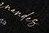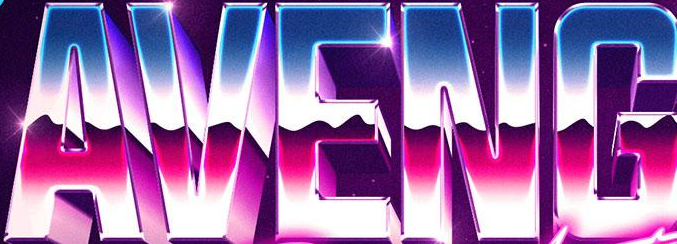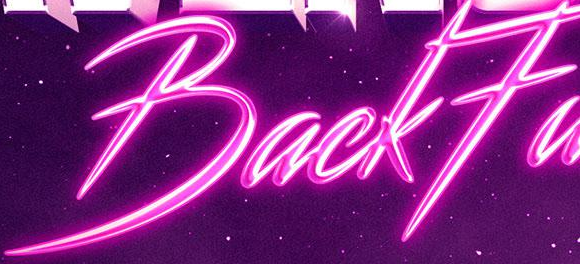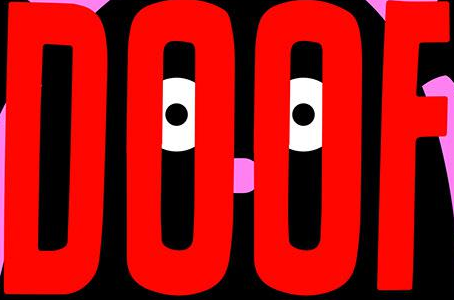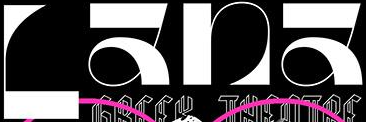What words are shown in these images in order, separated by a semicolon? #####; AVENG; BackFa; DOOF; Lana 